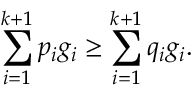<formula> <loc_0><loc_0><loc_500><loc_500>\sum _ { i = 1 } ^ { k + 1 } p _ { i } g _ { i } \geq \sum _ { i = 1 } ^ { k + 1 } q _ { i } g _ { i } .</formula> 